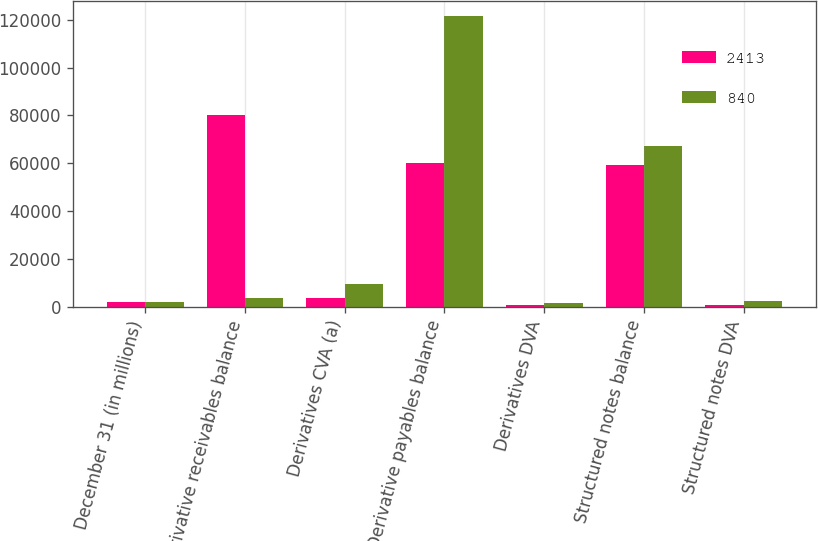Convert chart. <chart><loc_0><loc_0><loc_500><loc_500><stacked_bar_chart><ecel><fcel>December 31 (in millions)<fcel>Derivative receivables balance<fcel>Derivatives CVA (a)<fcel>Derivative payables balance<fcel>Derivatives DVA<fcel>Structured notes balance<fcel>Structured notes DVA<nl><fcel>2413<fcel>2009<fcel>80210<fcel>3697<fcel>60125<fcel>629<fcel>59064<fcel>840<nl><fcel>840<fcel>2008<fcel>3697<fcel>9566<fcel>121604<fcel>1389<fcel>67340<fcel>2413<nl></chart> 